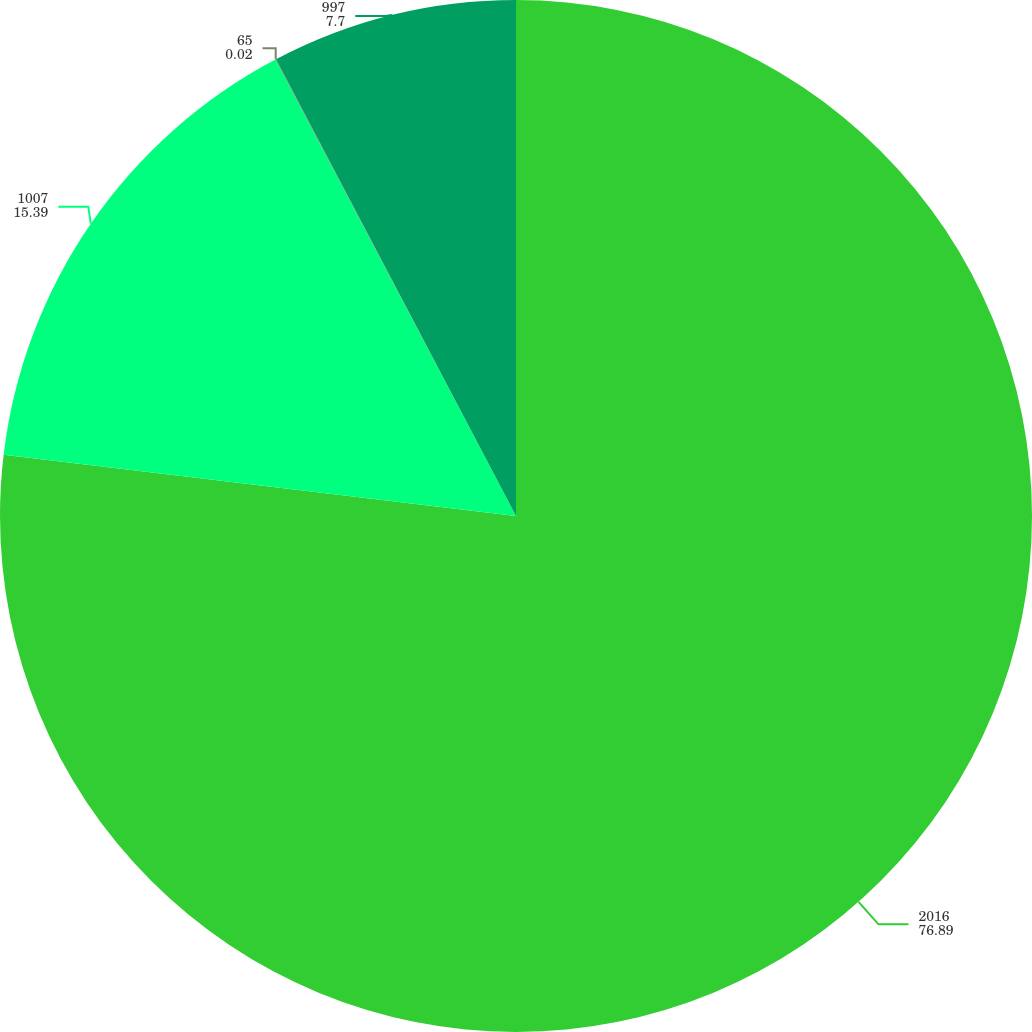<chart> <loc_0><loc_0><loc_500><loc_500><pie_chart><fcel>2016<fcel>1007<fcel>65<fcel>997<nl><fcel>76.89%<fcel>15.39%<fcel>0.02%<fcel>7.7%<nl></chart> 